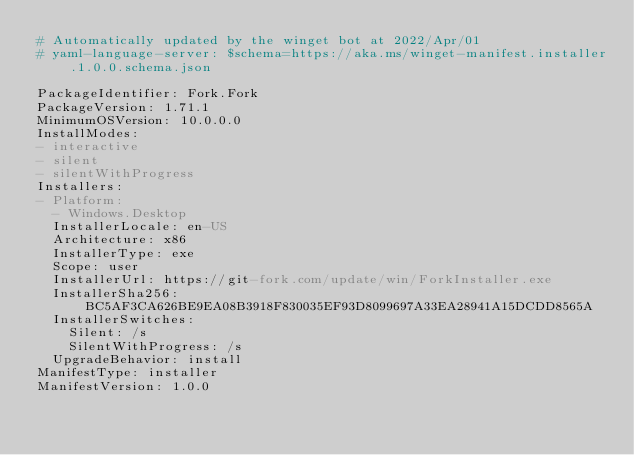<code> <loc_0><loc_0><loc_500><loc_500><_YAML_># Automatically updated by the winget bot at 2022/Apr/01
# yaml-language-server: $schema=https://aka.ms/winget-manifest.installer.1.0.0.schema.json

PackageIdentifier: Fork.Fork
PackageVersion: 1.71.1
MinimumOSVersion: 10.0.0.0
InstallModes:
- interactive
- silent
- silentWithProgress
Installers:
- Platform:
  - Windows.Desktop
  InstallerLocale: en-US
  Architecture: x86
  InstallerType: exe
  Scope: user
  InstallerUrl: https://git-fork.com/update/win/ForkInstaller.exe
  InstallerSha256: BC5AF3CA626BE9EA08B3918F830035EF93D8099697A33EA28941A15DCDD8565A
  InstallerSwitches:
    Silent: /s
    SilentWithProgress: /s
  UpgradeBehavior: install
ManifestType: installer
ManifestVersion: 1.0.0
</code> 